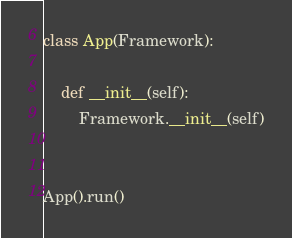Convert code to text. <code><loc_0><loc_0><loc_500><loc_500><_Python_>
class App(Framework):

    def __init__(self):
        Framework.__init__(self)


App().run()
</code> 